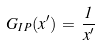Convert formula to latex. <formula><loc_0><loc_0><loc_500><loc_500>G _ { I \, P } ( x ^ { \prime } ) \, = \, \frac { 1 } { x ^ { \prime } }</formula> 